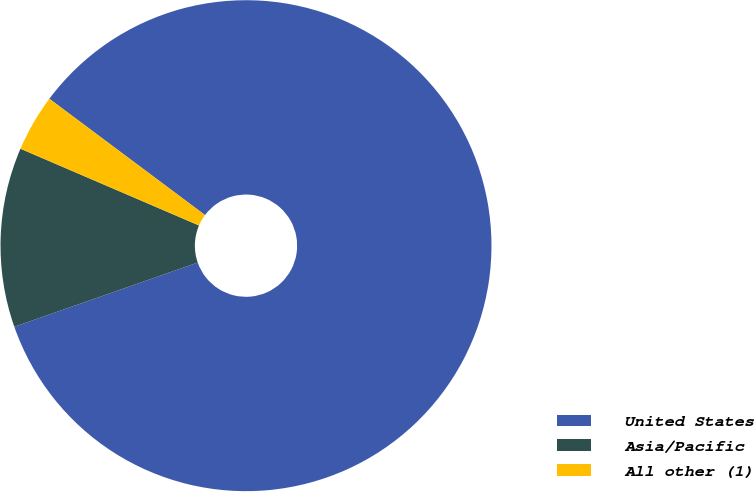<chart> <loc_0><loc_0><loc_500><loc_500><pie_chart><fcel>United States<fcel>Asia/Pacific<fcel>All other (1)<nl><fcel>84.43%<fcel>11.82%<fcel>3.75%<nl></chart> 